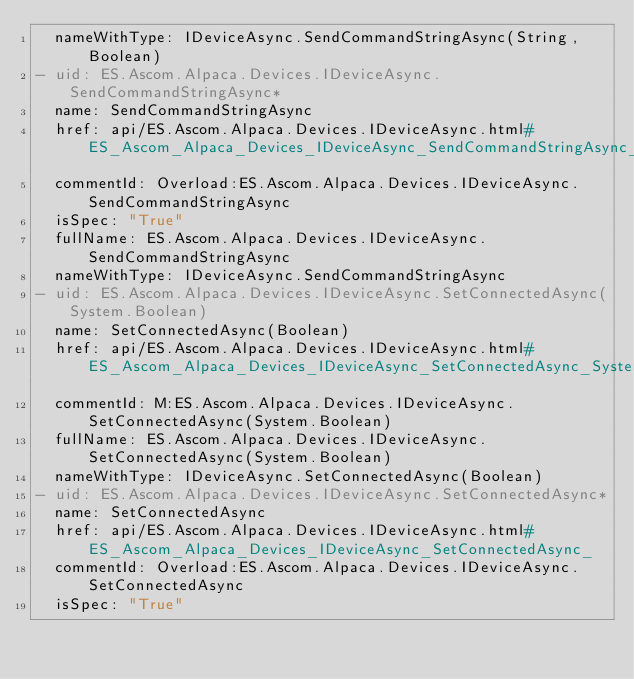<code> <loc_0><loc_0><loc_500><loc_500><_YAML_>  nameWithType: IDeviceAsync.SendCommandStringAsync(String, Boolean)
- uid: ES.Ascom.Alpaca.Devices.IDeviceAsync.SendCommandStringAsync*
  name: SendCommandStringAsync
  href: api/ES.Ascom.Alpaca.Devices.IDeviceAsync.html#ES_Ascom_Alpaca_Devices_IDeviceAsync_SendCommandStringAsync_
  commentId: Overload:ES.Ascom.Alpaca.Devices.IDeviceAsync.SendCommandStringAsync
  isSpec: "True"
  fullName: ES.Ascom.Alpaca.Devices.IDeviceAsync.SendCommandStringAsync
  nameWithType: IDeviceAsync.SendCommandStringAsync
- uid: ES.Ascom.Alpaca.Devices.IDeviceAsync.SetConnectedAsync(System.Boolean)
  name: SetConnectedAsync(Boolean)
  href: api/ES.Ascom.Alpaca.Devices.IDeviceAsync.html#ES_Ascom_Alpaca_Devices_IDeviceAsync_SetConnectedAsync_System_Boolean_
  commentId: M:ES.Ascom.Alpaca.Devices.IDeviceAsync.SetConnectedAsync(System.Boolean)
  fullName: ES.Ascom.Alpaca.Devices.IDeviceAsync.SetConnectedAsync(System.Boolean)
  nameWithType: IDeviceAsync.SetConnectedAsync(Boolean)
- uid: ES.Ascom.Alpaca.Devices.IDeviceAsync.SetConnectedAsync*
  name: SetConnectedAsync
  href: api/ES.Ascom.Alpaca.Devices.IDeviceAsync.html#ES_Ascom_Alpaca_Devices_IDeviceAsync_SetConnectedAsync_
  commentId: Overload:ES.Ascom.Alpaca.Devices.IDeviceAsync.SetConnectedAsync
  isSpec: "True"</code> 